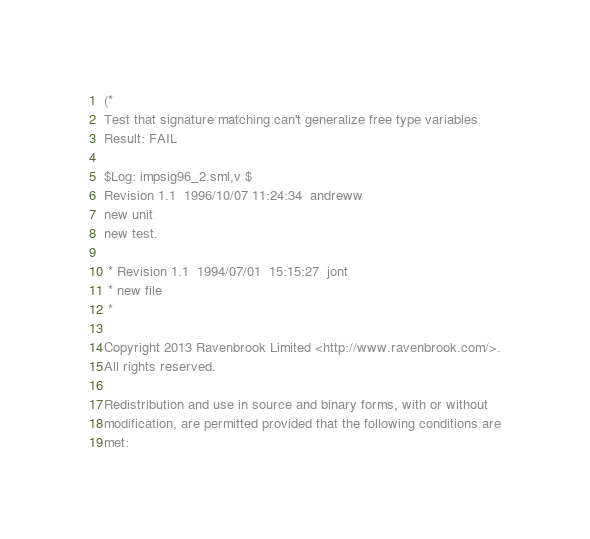Convert code to text. <code><loc_0><loc_0><loc_500><loc_500><_SML_>(*
Test that signature matching can't generalize free type variables
Result: FAIL
 
$Log: impsig96_2.sml,v $
Revision 1.1  1996/10/07 11:24:34  andreww
new unit
new test.

 * Revision 1.1  1994/07/01  15:15:27  jont
 * new file
 *

Copyright 2013 Ravenbrook Limited <http://www.ravenbrook.com/>.
All rights reserved.

Redistribution and use in source and binary forms, with or without
modification, are permitted provided that the following conditions are
met:
</code> 